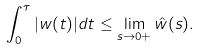<formula> <loc_0><loc_0><loc_500><loc_500>\int _ { 0 } ^ { \tau } | w ( t ) | d t \leq \lim _ { s \rightarrow 0 + } \hat { w } ( s ) .</formula> 